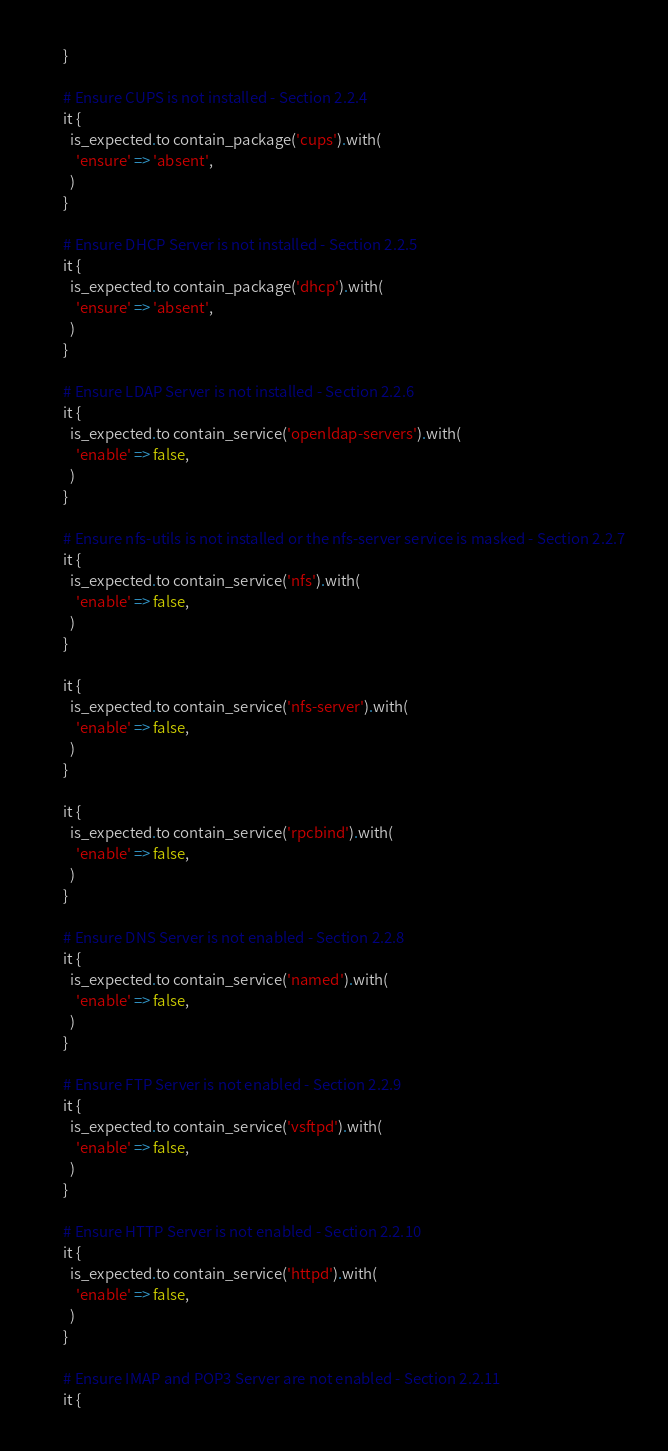Convert code to text. <code><loc_0><loc_0><loc_500><loc_500><_Ruby_>      }

      # Ensure CUPS is not installed - Section 2.2.4
      it {
        is_expected.to contain_package('cups').with(
          'ensure' => 'absent',
        )
      }

      # Ensure DHCP Server is not installed - Section 2.2.5
      it {
        is_expected.to contain_package('dhcp').with(
          'ensure' => 'absent',
        )
      }

      # Ensure LDAP Server is not installed - Section 2.2.6
      it {
        is_expected.to contain_service('openldap-servers').with(
          'enable' => false,
        )
      }

      # Ensure nfs-utils is not installed or the nfs-server service is masked - Section 2.2.7
      it {
        is_expected.to contain_service('nfs').with(
          'enable' => false,
        )
      }

      it {
        is_expected.to contain_service('nfs-server').with(
          'enable' => false,
        )
      }

      it {
        is_expected.to contain_service('rpcbind').with(
          'enable' => false,
        )
      }

      # Ensure DNS Server is not enabled - Section 2.2.8
      it {
        is_expected.to contain_service('named').with(
          'enable' => false,
        )
      }

      # Ensure FTP Server is not enabled - Section 2.2.9
      it {
        is_expected.to contain_service('vsftpd').with(
          'enable' => false,
        )
      }

      # Ensure HTTP Server is not enabled - Section 2.2.10
      it {
        is_expected.to contain_service('httpd').with(
          'enable' => false,
        )
      }

      # Ensure IMAP and POP3 Server are not enabled - Section 2.2.11
      it {</code> 